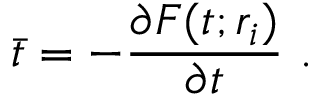<formula> <loc_0><loc_0><loc_500><loc_500>\bar { t } = - { \frac { \partial F ( t ; r _ { i } ) } { \partial t } } \ .</formula> 